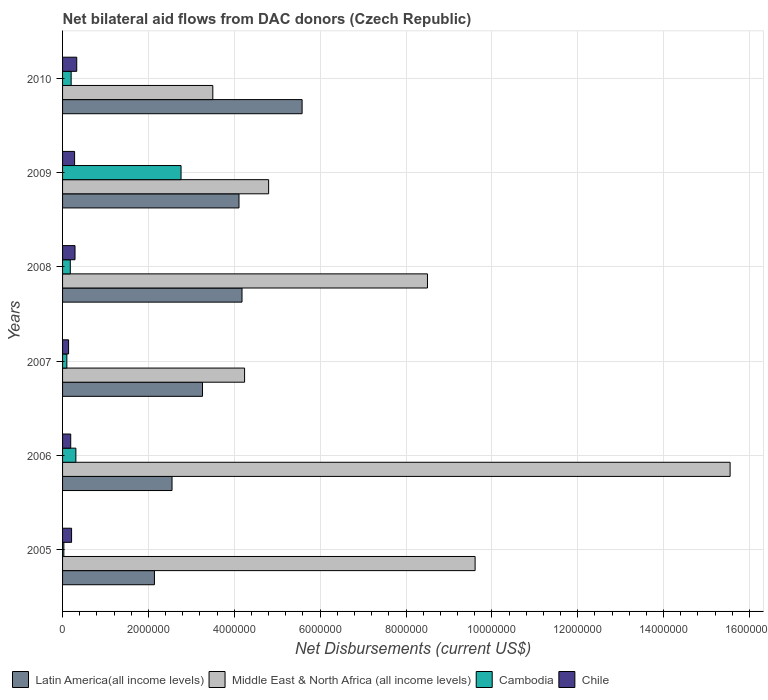How many bars are there on the 4th tick from the top?
Give a very brief answer. 4. How many bars are there on the 6th tick from the bottom?
Give a very brief answer. 4. What is the net bilateral aid flows in Latin America(all income levels) in 2008?
Provide a succinct answer. 4.18e+06. Across all years, what is the maximum net bilateral aid flows in Cambodia?
Your answer should be compact. 2.76e+06. Across all years, what is the minimum net bilateral aid flows in Middle East & North Africa (all income levels)?
Make the answer very short. 3.50e+06. In which year was the net bilateral aid flows in Cambodia maximum?
Ensure brevity in your answer.  2009. In which year was the net bilateral aid flows in Chile minimum?
Ensure brevity in your answer.  2007. What is the total net bilateral aid flows in Latin America(all income levels) in the graph?
Your response must be concise. 2.18e+07. What is the difference between the net bilateral aid flows in Cambodia in 2008 and that in 2009?
Your answer should be very brief. -2.58e+06. What is the difference between the net bilateral aid flows in Latin America(all income levels) in 2006 and the net bilateral aid flows in Middle East & North Africa (all income levels) in 2010?
Give a very brief answer. -9.50e+05. What is the average net bilateral aid flows in Middle East & North Africa (all income levels) per year?
Provide a succinct answer. 7.70e+06. In the year 2008, what is the difference between the net bilateral aid flows in Cambodia and net bilateral aid flows in Middle East & North Africa (all income levels)?
Give a very brief answer. -8.32e+06. What is the ratio of the net bilateral aid flows in Middle East & North Africa (all income levels) in 2005 to that in 2009?
Offer a very short reply. 2. Is the net bilateral aid flows in Latin America(all income levels) in 2007 less than that in 2010?
Your response must be concise. Yes. What is the difference between the highest and the second highest net bilateral aid flows in Middle East & North Africa (all income levels)?
Offer a terse response. 5.94e+06. What is the difference between the highest and the lowest net bilateral aid flows in Middle East & North Africa (all income levels)?
Make the answer very short. 1.20e+07. Is the sum of the net bilateral aid flows in Chile in 2007 and 2010 greater than the maximum net bilateral aid flows in Latin America(all income levels) across all years?
Offer a very short reply. No. Is it the case that in every year, the sum of the net bilateral aid flows in Latin America(all income levels) and net bilateral aid flows in Chile is greater than the sum of net bilateral aid flows in Middle East & North Africa (all income levels) and net bilateral aid flows in Cambodia?
Keep it short and to the point. No. What does the 4th bar from the top in 2010 represents?
Your answer should be compact. Latin America(all income levels). What does the 2nd bar from the bottom in 2009 represents?
Offer a terse response. Middle East & North Africa (all income levels). How many bars are there?
Provide a succinct answer. 24. Are all the bars in the graph horizontal?
Offer a terse response. Yes. Are the values on the major ticks of X-axis written in scientific E-notation?
Ensure brevity in your answer.  No. Does the graph contain any zero values?
Your answer should be very brief. No. Does the graph contain grids?
Keep it short and to the point. Yes. What is the title of the graph?
Offer a very short reply. Net bilateral aid flows from DAC donors (Czech Republic). What is the label or title of the X-axis?
Make the answer very short. Net Disbursements (current US$). What is the Net Disbursements (current US$) of Latin America(all income levels) in 2005?
Your answer should be very brief. 2.14e+06. What is the Net Disbursements (current US$) in Middle East & North Africa (all income levels) in 2005?
Offer a terse response. 9.61e+06. What is the Net Disbursements (current US$) of Latin America(all income levels) in 2006?
Keep it short and to the point. 2.55e+06. What is the Net Disbursements (current US$) of Middle East & North Africa (all income levels) in 2006?
Your answer should be compact. 1.56e+07. What is the Net Disbursements (current US$) in Chile in 2006?
Provide a succinct answer. 1.90e+05. What is the Net Disbursements (current US$) of Latin America(all income levels) in 2007?
Your answer should be very brief. 3.26e+06. What is the Net Disbursements (current US$) in Middle East & North Africa (all income levels) in 2007?
Give a very brief answer. 4.24e+06. What is the Net Disbursements (current US$) in Cambodia in 2007?
Make the answer very short. 1.00e+05. What is the Net Disbursements (current US$) of Latin America(all income levels) in 2008?
Keep it short and to the point. 4.18e+06. What is the Net Disbursements (current US$) of Middle East & North Africa (all income levels) in 2008?
Provide a short and direct response. 8.50e+06. What is the Net Disbursements (current US$) of Latin America(all income levels) in 2009?
Provide a succinct answer. 4.11e+06. What is the Net Disbursements (current US$) of Middle East & North Africa (all income levels) in 2009?
Provide a short and direct response. 4.80e+06. What is the Net Disbursements (current US$) in Cambodia in 2009?
Keep it short and to the point. 2.76e+06. What is the Net Disbursements (current US$) in Latin America(all income levels) in 2010?
Your answer should be compact. 5.58e+06. What is the Net Disbursements (current US$) of Middle East & North Africa (all income levels) in 2010?
Provide a succinct answer. 3.50e+06. What is the Net Disbursements (current US$) in Cambodia in 2010?
Your answer should be very brief. 2.00e+05. What is the Net Disbursements (current US$) in Chile in 2010?
Your response must be concise. 3.30e+05. Across all years, what is the maximum Net Disbursements (current US$) in Latin America(all income levels)?
Your answer should be compact. 5.58e+06. Across all years, what is the maximum Net Disbursements (current US$) of Middle East & North Africa (all income levels)?
Offer a terse response. 1.56e+07. Across all years, what is the maximum Net Disbursements (current US$) in Cambodia?
Provide a short and direct response. 2.76e+06. Across all years, what is the maximum Net Disbursements (current US$) of Chile?
Make the answer very short. 3.30e+05. Across all years, what is the minimum Net Disbursements (current US$) of Latin America(all income levels)?
Keep it short and to the point. 2.14e+06. Across all years, what is the minimum Net Disbursements (current US$) in Middle East & North Africa (all income levels)?
Provide a succinct answer. 3.50e+06. Across all years, what is the minimum Net Disbursements (current US$) in Cambodia?
Offer a terse response. 3.00e+04. Across all years, what is the minimum Net Disbursements (current US$) in Chile?
Your answer should be very brief. 1.40e+05. What is the total Net Disbursements (current US$) of Latin America(all income levels) in the graph?
Your response must be concise. 2.18e+07. What is the total Net Disbursements (current US$) in Middle East & North Africa (all income levels) in the graph?
Make the answer very short. 4.62e+07. What is the total Net Disbursements (current US$) in Cambodia in the graph?
Offer a very short reply. 3.58e+06. What is the total Net Disbursements (current US$) in Chile in the graph?
Your response must be concise. 1.44e+06. What is the difference between the Net Disbursements (current US$) in Latin America(all income levels) in 2005 and that in 2006?
Your answer should be compact. -4.10e+05. What is the difference between the Net Disbursements (current US$) of Middle East & North Africa (all income levels) in 2005 and that in 2006?
Keep it short and to the point. -5.94e+06. What is the difference between the Net Disbursements (current US$) in Cambodia in 2005 and that in 2006?
Ensure brevity in your answer.  -2.80e+05. What is the difference between the Net Disbursements (current US$) of Chile in 2005 and that in 2006?
Provide a short and direct response. 2.00e+04. What is the difference between the Net Disbursements (current US$) in Latin America(all income levels) in 2005 and that in 2007?
Your response must be concise. -1.12e+06. What is the difference between the Net Disbursements (current US$) of Middle East & North Africa (all income levels) in 2005 and that in 2007?
Keep it short and to the point. 5.37e+06. What is the difference between the Net Disbursements (current US$) in Latin America(all income levels) in 2005 and that in 2008?
Give a very brief answer. -2.04e+06. What is the difference between the Net Disbursements (current US$) of Middle East & North Africa (all income levels) in 2005 and that in 2008?
Ensure brevity in your answer.  1.11e+06. What is the difference between the Net Disbursements (current US$) in Cambodia in 2005 and that in 2008?
Your answer should be compact. -1.50e+05. What is the difference between the Net Disbursements (current US$) in Chile in 2005 and that in 2008?
Offer a very short reply. -8.00e+04. What is the difference between the Net Disbursements (current US$) in Latin America(all income levels) in 2005 and that in 2009?
Your answer should be very brief. -1.97e+06. What is the difference between the Net Disbursements (current US$) of Middle East & North Africa (all income levels) in 2005 and that in 2009?
Keep it short and to the point. 4.81e+06. What is the difference between the Net Disbursements (current US$) in Cambodia in 2005 and that in 2009?
Give a very brief answer. -2.73e+06. What is the difference between the Net Disbursements (current US$) in Chile in 2005 and that in 2009?
Keep it short and to the point. -7.00e+04. What is the difference between the Net Disbursements (current US$) of Latin America(all income levels) in 2005 and that in 2010?
Your answer should be very brief. -3.44e+06. What is the difference between the Net Disbursements (current US$) in Middle East & North Africa (all income levels) in 2005 and that in 2010?
Ensure brevity in your answer.  6.11e+06. What is the difference between the Net Disbursements (current US$) of Cambodia in 2005 and that in 2010?
Ensure brevity in your answer.  -1.70e+05. What is the difference between the Net Disbursements (current US$) of Chile in 2005 and that in 2010?
Offer a terse response. -1.20e+05. What is the difference between the Net Disbursements (current US$) of Latin America(all income levels) in 2006 and that in 2007?
Offer a terse response. -7.10e+05. What is the difference between the Net Disbursements (current US$) in Middle East & North Africa (all income levels) in 2006 and that in 2007?
Make the answer very short. 1.13e+07. What is the difference between the Net Disbursements (current US$) in Cambodia in 2006 and that in 2007?
Give a very brief answer. 2.10e+05. What is the difference between the Net Disbursements (current US$) in Latin America(all income levels) in 2006 and that in 2008?
Give a very brief answer. -1.63e+06. What is the difference between the Net Disbursements (current US$) in Middle East & North Africa (all income levels) in 2006 and that in 2008?
Your answer should be very brief. 7.05e+06. What is the difference between the Net Disbursements (current US$) of Cambodia in 2006 and that in 2008?
Your answer should be compact. 1.30e+05. What is the difference between the Net Disbursements (current US$) of Latin America(all income levels) in 2006 and that in 2009?
Make the answer very short. -1.56e+06. What is the difference between the Net Disbursements (current US$) of Middle East & North Africa (all income levels) in 2006 and that in 2009?
Provide a succinct answer. 1.08e+07. What is the difference between the Net Disbursements (current US$) of Cambodia in 2006 and that in 2009?
Your answer should be very brief. -2.45e+06. What is the difference between the Net Disbursements (current US$) in Chile in 2006 and that in 2009?
Keep it short and to the point. -9.00e+04. What is the difference between the Net Disbursements (current US$) in Latin America(all income levels) in 2006 and that in 2010?
Give a very brief answer. -3.03e+06. What is the difference between the Net Disbursements (current US$) of Middle East & North Africa (all income levels) in 2006 and that in 2010?
Give a very brief answer. 1.20e+07. What is the difference between the Net Disbursements (current US$) in Cambodia in 2006 and that in 2010?
Offer a terse response. 1.10e+05. What is the difference between the Net Disbursements (current US$) of Latin America(all income levels) in 2007 and that in 2008?
Offer a very short reply. -9.20e+05. What is the difference between the Net Disbursements (current US$) in Middle East & North Africa (all income levels) in 2007 and that in 2008?
Provide a short and direct response. -4.26e+06. What is the difference between the Net Disbursements (current US$) in Latin America(all income levels) in 2007 and that in 2009?
Give a very brief answer. -8.50e+05. What is the difference between the Net Disbursements (current US$) of Middle East & North Africa (all income levels) in 2007 and that in 2009?
Give a very brief answer. -5.60e+05. What is the difference between the Net Disbursements (current US$) of Cambodia in 2007 and that in 2009?
Offer a terse response. -2.66e+06. What is the difference between the Net Disbursements (current US$) of Latin America(all income levels) in 2007 and that in 2010?
Provide a short and direct response. -2.32e+06. What is the difference between the Net Disbursements (current US$) in Middle East & North Africa (all income levels) in 2007 and that in 2010?
Ensure brevity in your answer.  7.40e+05. What is the difference between the Net Disbursements (current US$) in Cambodia in 2007 and that in 2010?
Give a very brief answer. -1.00e+05. What is the difference between the Net Disbursements (current US$) in Middle East & North Africa (all income levels) in 2008 and that in 2009?
Keep it short and to the point. 3.70e+06. What is the difference between the Net Disbursements (current US$) of Cambodia in 2008 and that in 2009?
Keep it short and to the point. -2.58e+06. What is the difference between the Net Disbursements (current US$) of Chile in 2008 and that in 2009?
Your answer should be very brief. 10000. What is the difference between the Net Disbursements (current US$) in Latin America(all income levels) in 2008 and that in 2010?
Offer a very short reply. -1.40e+06. What is the difference between the Net Disbursements (current US$) in Middle East & North Africa (all income levels) in 2008 and that in 2010?
Make the answer very short. 5.00e+06. What is the difference between the Net Disbursements (current US$) in Cambodia in 2008 and that in 2010?
Ensure brevity in your answer.  -2.00e+04. What is the difference between the Net Disbursements (current US$) of Latin America(all income levels) in 2009 and that in 2010?
Provide a short and direct response. -1.47e+06. What is the difference between the Net Disbursements (current US$) in Middle East & North Africa (all income levels) in 2009 and that in 2010?
Keep it short and to the point. 1.30e+06. What is the difference between the Net Disbursements (current US$) of Cambodia in 2009 and that in 2010?
Provide a succinct answer. 2.56e+06. What is the difference between the Net Disbursements (current US$) in Chile in 2009 and that in 2010?
Your answer should be compact. -5.00e+04. What is the difference between the Net Disbursements (current US$) of Latin America(all income levels) in 2005 and the Net Disbursements (current US$) of Middle East & North Africa (all income levels) in 2006?
Your response must be concise. -1.34e+07. What is the difference between the Net Disbursements (current US$) in Latin America(all income levels) in 2005 and the Net Disbursements (current US$) in Cambodia in 2006?
Offer a terse response. 1.83e+06. What is the difference between the Net Disbursements (current US$) in Latin America(all income levels) in 2005 and the Net Disbursements (current US$) in Chile in 2006?
Provide a short and direct response. 1.95e+06. What is the difference between the Net Disbursements (current US$) of Middle East & North Africa (all income levels) in 2005 and the Net Disbursements (current US$) of Cambodia in 2006?
Your answer should be very brief. 9.30e+06. What is the difference between the Net Disbursements (current US$) in Middle East & North Africa (all income levels) in 2005 and the Net Disbursements (current US$) in Chile in 2006?
Provide a succinct answer. 9.42e+06. What is the difference between the Net Disbursements (current US$) of Latin America(all income levels) in 2005 and the Net Disbursements (current US$) of Middle East & North Africa (all income levels) in 2007?
Give a very brief answer. -2.10e+06. What is the difference between the Net Disbursements (current US$) in Latin America(all income levels) in 2005 and the Net Disbursements (current US$) in Cambodia in 2007?
Make the answer very short. 2.04e+06. What is the difference between the Net Disbursements (current US$) of Middle East & North Africa (all income levels) in 2005 and the Net Disbursements (current US$) of Cambodia in 2007?
Your response must be concise. 9.51e+06. What is the difference between the Net Disbursements (current US$) in Middle East & North Africa (all income levels) in 2005 and the Net Disbursements (current US$) in Chile in 2007?
Your answer should be very brief. 9.47e+06. What is the difference between the Net Disbursements (current US$) of Latin America(all income levels) in 2005 and the Net Disbursements (current US$) of Middle East & North Africa (all income levels) in 2008?
Your answer should be very brief. -6.36e+06. What is the difference between the Net Disbursements (current US$) in Latin America(all income levels) in 2005 and the Net Disbursements (current US$) in Cambodia in 2008?
Your response must be concise. 1.96e+06. What is the difference between the Net Disbursements (current US$) of Latin America(all income levels) in 2005 and the Net Disbursements (current US$) of Chile in 2008?
Offer a very short reply. 1.85e+06. What is the difference between the Net Disbursements (current US$) of Middle East & North Africa (all income levels) in 2005 and the Net Disbursements (current US$) of Cambodia in 2008?
Keep it short and to the point. 9.43e+06. What is the difference between the Net Disbursements (current US$) in Middle East & North Africa (all income levels) in 2005 and the Net Disbursements (current US$) in Chile in 2008?
Give a very brief answer. 9.32e+06. What is the difference between the Net Disbursements (current US$) in Cambodia in 2005 and the Net Disbursements (current US$) in Chile in 2008?
Offer a terse response. -2.60e+05. What is the difference between the Net Disbursements (current US$) in Latin America(all income levels) in 2005 and the Net Disbursements (current US$) in Middle East & North Africa (all income levels) in 2009?
Keep it short and to the point. -2.66e+06. What is the difference between the Net Disbursements (current US$) of Latin America(all income levels) in 2005 and the Net Disbursements (current US$) of Cambodia in 2009?
Keep it short and to the point. -6.20e+05. What is the difference between the Net Disbursements (current US$) in Latin America(all income levels) in 2005 and the Net Disbursements (current US$) in Chile in 2009?
Provide a succinct answer. 1.86e+06. What is the difference between the Net Disbursements (current US$) of Middle East & North Africa (all income levels) in 2005 and the Net Disbursements (current US$) of Cambodia in 2009?
Your response must be concise. 6.85e+06. What is the difference between the Net Disbursements (current US$) of Middle East & North Africa (all income levels) in 2005 and the Net Disbursements (current US$) of Chile in 2009?
Provide a short and direct response. 9.33e+06. What is the difference between the Net Disbursements (current US$) in Latin America(all income levels) in 2005 and the Net Disbursements (current US$) in Middle East & North Africa (all income levels) in 2010?
Provide a succinct answer. -1.36e+06. What is the difference between the Net Disbursements (current US$) in Latin America(all income levels) in 2005 and the Net Disbursements (current US$) in Cambodia in 2010?
Offer a very short reply. 1.94e+06. What is the difference between the Net Disbursements (current US$) in Latin America(all income levels) in 2005 and the Net Disbursements (current US$) in Chile in 2010?
Give a very brief answer. 1.81e+06. What is the difference between the Net Disbursements (current US$) of Middle East & North Africa (all income levels) in 2005 and the Net Disbursements (current US$) of Cambodia in 2010?
Provide a short and direct response. 9.41e+06. What is the difference between the Net Disbursements (current US$) in Middle East & North Africa (all income levels) in 2005 and the Net Disbursements (current US$) in Chile in 2010?
Your response must be concise. 9.28e+06. What is the difference between the Net Disbursements (current US$) of Latin America(all income levels) in 2006 and the Net Disbursements (current US$) of Middle East & North Africa (all income levels) in 2007?
Give a very brief answer. -1.69e+06. What is the difference between the Net Disbursements (current US$) of Latin America(all income levels) in 2006 and the Net Disbursements (current US$) of Cambodia in 2007?
Make the answer very short. 2.45e+06. What is the difference between the Net Disbursements (current US$) in Latin America(all income levels) in 2006 and the Net Disbursements (current US$) in Chile in 2007?
Give a very brief answer. 2.41e+06. What is the difference between the Net Disbursements (current US$) in Middle East & North Africa (all income levels) in 2006 and the Net Disbursements (current US$) in Cambodia in 2007?
Your answer should be compact. 1.54e+07. What is the difference between the Net Disbursements (current US$) of Middle East & North Africa (all income levels) in 2006 and the Net Disbursements (current US$) of Chile in 2007?
Provide a succinct answer. 1.54e+07. What is the difference between the Net Disbursements (current US$) of Latin America(all income levels) in 2006 and the Net Disbursements (current US$) of Middle East & North Africa (all income levels) in 2008?
Provide a short and direct response. -5.95e+06. What is the difference between the Net Disbursements (current US$) of Latin America(all income levels) in 2006 and the Net Disbursements (current US$) of Cambodia in 2008?
Your response must be concise. 2.37e+06. What is the difference between the Net Disbursements (current US$) of Latin America(all income levels) in 2006 and the Net Disbursements (current US$) of Chile in 2008?
Your answer should be compact. 2.26e+06. What is the difference between the Net Disbursements (current US$) in Middle East & North Africa (all income levels) in 2006 and the Net Disbursements (current US$) in Cambodia in 2008?
Your answer should be compact. 1.54e+07. What is the difference between the Net Disbursements (current US$) in Middle East & North Africa (all income levels) in 2006 and the Net Disbursements (current US$) in Chile in 2008?
Provide a succinct answer. 1.53e+07. What is the difference between the Net Disbursements (current US$) of Latin America(all income levels) in 2006 and the Net Disbursements (current US$) of Middle East & North Africa (all income levels) in 2009?
Your answer should be very brief. -2.25e+06. What is the difference between the Net Disbursements (current US$) of Latin America(all income levels) in 2006 and the Net Disbursements (current US$) of Cambodia in 2009?
Ensure brevity in your answer.  -2.10e+05. What is the difference between the Net Disbursements (current US$) of Latin America(all income levels) in 2006 and the Net Disbursements (current US$) of Chile in 2009?
Your answer should be compact. 2.27e+06. What is the difference between the Net Disbursements (current US$) in Middle East & North Africa (all income levels) in 2006 and the Net Disbursements (current US$) in Cambodia in 2009?
Your answer should be compact. 1.28e+07. What is the difference between the Net Disbursements (current US$) of Middle East & North Africa (all income levels) in 2006 and the Net Disbursements (current US$) of Chile in 2009?
Provide a short and direct response. 1.53e+07. What is the difference between the Net Disbursements (current US$) of Latin America(all income levels) in 2006 and the Net Disbursements (current US$) of Middle East & North Africa (all income levels) in 2010?
Keep it short and to the point. -9.50e+05. What is the difference between the Net Disbursements (current US$) of Latin America(all income levels) in 2006 and the Net Disbursements (current US$) of Cambodia in 2010?
Your answer should be very brief. 2.35e+06. What is the difference between the Net Disbursements (current US$) in Latin America(all income levels) in 2006 and the Net Disbursements (current US$) in Chile in 2010?
Offer a very short reply. 2.22e+06. What is the difference between the Net Disbursements (current US$) in Middle East & North Africa (all income levels) in 2006 and the Net Disbursements (current US$) in Cambodia in 2010?
Offer a terse response. 1.54e+07. What is the difference between the Net Disbursements (current US$) in Middle East & North Africa (all income levels) in 2006 and the Net Disbursements (current US$) in Chile in 2010?
Provide a short and direct response. 1.52e+07. What is the difference between the Net Disbursements (current US$) of Latin America(all income levels) in 2007 and the Net Disbursements (current US$) of Middle East & North Africa (all income levels) in 2008?
Your answer should be compact. -5.24e+06. What is the difference between the Net Disbursements (current US$) of Latin America(all income levels) in 2007 and the Net Disbursements (current US$) of Cambodia in 2008?
Offer a very short reply. 3.08e+06. What is the difference between the Net Disbursements (current US$) of Latin America(all income levels) in 2007 and the Net Disbursements (current US$) of Chile in 2008?
Provide a short and direct response. 2.97e+06. What is the difference between the Net Disbursements (current US$) in Middle East & North Africa (all income levels) in 2007 and the Net Disbursements (current US$) in Cambodia in 2008?
Offer a terse response. 4.06e+06. What is the difference between the Net Disbursements (current US$) in Middle East & North Africa (all income levels) in 2007 and the Net Disbursements (current US$) in Chile in 2008?
Your answer should be compact. 3.95e+06. What is the difference between the Net Disbursements (current US$) of Cambodia in 2007 and the Net Disbursements (current US$) of Chile in 2008?
Provide a succinct answer. -1.90e+05. What is the difference between the Net Disbursements (current US$) in Latin America(all income levels) in 2007 and the Net Disbursements (current US$) in Middle East & North Africa (all income levels) in 2009?
Make the answer very short. -1.54e+06. What is the difference between the Net Disbursements (current US$) in Latin America(all income levels) in 2007 and the Net Disbursements (current US$) in Cambodia in 2009?
Provide a short and direct response. 5.00e+05. What is the difference between the Net Disbursements (current US$) of Latin America(all income levels) in 2007 and the Net Disbursements (current US$) of Chile in 2009?
Make the answer very short. 2.98e+06. What is the difference between the Net Disbursements (current US$) of Middle East & North Africa (all income levels) in 2007 and the Net Disbursements (current US$) of Cambodia in 2009?
Give a very brief answer. 1.48e+06. What is the difference between the Net Disbursements (current US$) of Middle East & North Africa (all income levels) in 2007 and the Net Disbursements (current US$) of Chile in 2009?
Give a very brief answer. 3.96e+06. What is the difference between the Net Disbursements (current US$) of Latin America(all income levels) in 2007 and the Net Disbursements (current US$) of Cambodia in 2010?
Keep it short and to the point. 3.06e+06. What is the difference between the Net Disbursements (current US$) of Latin America(all income levels) in 2007 and the Net Disbursements (current US$) of Chile in 2010?
Give a very brief answer. 2.93e+06. What is the difference between the Net Disbursements (current US$) in Middle East & North Africa (all income levels) in 2007 and the Net Disbursements (current US$) in Cambodia in 2010?
Your answer should be very brief. 4.04e+06. What is the difference between the Net Disbursements (current US$) in Middle East & North Africa (all income levels) in 2007 and the Net Disbursements (current US$) in Chile in 2010?
Make the answer very short. 3.91e+06. What is the difference between the Net Disbursements (current US$) in Latin America(all income levels) in 2008 and the Net Disbursements (current US$) in Middle East & North Africa (all income levels) in 2009?
Your response must be concise. -6.20e+05. What is the difference between the Net Disbursements (current US$) of Latin America(all income levels) in 2008 and the Net Disbursements (current US$) of Cambodia in 2009?
Your answer should be compact. 1.42e+06. What is the difference between the Net Disbursements (current US$) of Latin America(all income levels) in 2008 and the Net Disbursements (current US$) of Chile in 2009?
Offer a terse response. 3.90e+06. What is the difference between the Net Disbursements (current US$) in Middle East & North Africa (all income levels) in 2008 and the Net Disbursements (current US$) in Cambodia in 2009?
Ensure brevity in your answer.  5.74e+06. What is the difference between the Net Disbursements (current US$) of Middle East & North Africa (all income levels) in 2008 and the Net Disbursements (current US$) of Chile in 2009?
Provide a succinct answer. 8.22e+06. What is the difference between the Net Disbursements (current US$) in Latin America(all income levels) in 2008 and the Net Disbursements (current US$) in Middle East & North Africa (all income levels) in 2010?
Offer a very short reply. 6.80e+05. What is the difference between the Net Disbursements (current US$) of Latin America(all income levels) in 2008 and the Net Disbursements (current US$) of Cambodia in 2010?
Keep it short and to the point. 3.98e+06. What is the difference between the Net Disbursements (current US$) in Latin America(all income levels) in 2008 and the Net Disbursements (current US$) in Chile in 2010?
Make the answer very short. 3.85e+06. What is the difference between the Net Disbursements (current US$) in Middle East & North Africa (all income levels) in 2008 and the Net Disbursements (current US$) in Cambodia in 2010?
Provide a short and direct response. 8.30e+06. What is the difference between the Net Disbursements (current US$) of Middle East & North Africa (all income levels) in 2008 and the Net Disbursements (current US$) of Chile in 2010?
Offer a very short reply. 8.17e+06. What is the difference between the Net Disbursements (current US$) in Cambodia in 2008 and the Net Disbursements (current US$) in Chile in 2010?
Your answer should be compact. -1.50e+05. What is the difference between the Net Disbursements (current US$) in Latin America(all income levels) in 2009 and the Net Disbursements (current US$) in Cambodia in 2010?
Your response must be concise. 3.91e+06. What is the difference between the Net Disbursements (current US$) of Latin America(all income levels) in 2009 and the Net Disbursements (current US$) of Chile in 2010?
Ensure brevity in your answer.  3.78e+06. What is the difference between the Net Disbursements (current US$) of Middle East & North Africa (all income levels) in 2009 and the Net Disbursements (current US$) of Cambodia in 2010?
Give a very brief answer. 4.60e+06. What is the difference between the Net Disbursements (current US$) in Middle East & North Africa (all income levels) in 2009 and the Net Disbursements (current US$) in Chile in 2010?
Your response must be concise. 4.47e+06. What is the difference between the Net Disbursements (current US$) in Cambodia in 2009 and the Net Disbursements (current US$) in Chile in 2010?
Provide a short and direct response. 2.43e+06. What is the average Net Disbursements (current US$) of Latin America(all income levels) per year?
Offer a terse response. 3.64e+06. What is the average Net Disbursements (current US$) in Middle East & North Africa (all income levels) per year?
Make the answer very short. 7.70e+06. What is the average Net Disbursements (current US$) of Cambodia per year?
Ensure brevity in your answer.  5.97e+05. What is the average Net Disbursements (current US$) in Chile per year?
Provide a short and direct response. 2.40e+05. In the year 2005, what is the difference between the Net Disbursements (current US$) of Latin America(all income levels) and Net Disbursements (current US$) of Middle East & North Africa (all income levels)?
Provide a short and direct response. -7.47e+06. In the year 2005, what is the difference between the Net Disbursements (current US$) of Latin America(all income levels) and Net Disbursements (current US$) of Cambodia?
Offer a very short reply. 2.11e+06. In the year 2005, what is the difference between the Net Disbursements (current US$) of Latin America(all income levels) and Net Disbursements (current US$) of Chile?
Your response must be concise. 1.93e+06. In the year 2005, what is the difference between the Net Disbursements (current US$) in Middle East & North Africa (all income levels) and Net Disbursements (current US$) in Cambodia?
Give a very brief answer. 9.58e+06. In the year 2005, what is the difference between the Net Disbursements (current US$) in Middle East & North Africa (all income levels) and Net Disbursements (current US$) in Chile?
Offer a very short reply. 9.40e+06. In the year 2005, what is the difference between the Net Disbursements (current US$) in Cambodia and Net Disbursements (current US$) in Chile?
Give a very brief answer. -1.80e+05. In the year 2006, what is the difference between the Net Disbursements (current US$) in Latin America(all income levels) and Net Disbursements (current US$) in Middle East & North Africa (all income levels)?
Keep it short and to the point. -1.30e+07. In the year 2006, what is the difference between the Net Disbursements (current US$) in Latin America(all income levels) and Net Disbursements (current US$) in Cambodia?
Provide a short and direct response. 2.24e+06. In the year 2006, what is the difference between the Net Disbursements (current US$) of Latin America(all income levels) and Net Disbursements (current US$) of Chile?
Offer a terse response. 2.36e+06. In the year 2006, what is the difference between the Net Disbursements (current US$) of Middle East & North Africa (all income levels) and Net Disbursements (current US$) of Cambodia?
Give a very brief answer. 1.52e+07. In the year 2006, what is the difference between the Net Disbursements (current US$) of Middle East & North Africa (all income levels) and Net Disbursements (current US$) of Chile?
Your answer should be compact. 1.54e+07. In the year 2006, what is the difference between the Net Disbursements (current US$) of Cambodia and Net Disbursements (current US$) of Chile?
Give a very brief answer. 1.20e+05. In the year 2007, what is the difference between the Net Disbursements (current US$) in Latin America(all income levels) and Net Disbursements (current US$) in Middle East & North Africa (all income levels)?
Your answer should be very brief. -9.80e+05. In the year 2007, what is the difference between the Net Disbursements (current US$) of Latin America(all income levels) and Net Disbursements (current US$) of Cambodia?
Your answer should be very brief. 3.16e+06. In the year 2007, what is the difference between the Net Disbursements (current US$) of Latin America(all income levels) and Net Disbursements (current US$) of Chile?
Your response must be concise. 3.12e+06. In the year 2007, what is the difference between the Net Disbursements (current US$) of Middle East & North Africa (all income levels) and Net Disbursements (current US$) of Cambodia?
Your answer should be compact. 4.14e+06. In the year 2007, what is the difference between the Net Disbursements (current US$) in Middle East & North Africa (all income levels) and Net Disbursements (current US$) in Chile?
Offer a very short reply. 4.10e+06. In the year 2007, what is the difference between the Net Disbursements (current US$) in Cambodia and Net Disbursements (current US$) in Chile?
Provide a short and direct response. -4.00e+04. In the year 2008, what is the difference between the Net Disbursements (current US$) of Latin America(all income levels) and Net Disbursements (current US$) of Middle East & North Africa (all income levels)?
Offer a terse response. -4.32e+06. In the year 2008, what is the difference between the Net Disbursements (current US$) of Latin America(all income levels) and Net Disbursements (current US$) of Chile?
Provide a succinct answer. 3.89e+06. In the year 2008, what is the difference between the Net Disbursements (current US$) in Middle East & North Africa (all income levels) and Net Disbursements (current US$) in Cambodia?
Your answer should be very brief. 8.32e+06. In the year 2008, what is the difference between the Net Disbursements (current US$) of Middle East & North Africa (all income levels) and Net Disbursements (current US$) of Chile?
Your answer should be compact. 8.21e+06. In the year 2008, what is the difference between the Net Disbursements (current US$) in Cambodia and Net Disbursements (current US$) in Chile?
Your answer should be compact. -1.10e+05. In the year 2009, what is the difference between the Net Disbursements (current US$) of Latin America(all income levels) and Net Disbursements (current US$) of Middle East & North Africa (all income levels)?
Provide a short and direct response. -6.90e+05. In the year 2009, what is the difference between the Net Disbursements (current US$) in Latin America(all income levels) and Net Disbursements (current US$) in Cambodia?
Provide a succinct answer. 1.35e+06. In the year 2009, what is the difference between the Net Disbursements (current US$) of Latin America(all income levels) and Net Disbursements (current US$) of Chile?
Your answer should be compact. 3.83e+06. In the year 2009, what is the difference between the Net Disbursements (current US$) in Middle East & North Africa (all income levels) and Net Disbursements (current US$) in Cambodia?
Provide a succinct answer. 2.04e+06. In the year 2009, what is the difference between the Net Disbursements (current US$) in Middle East & North Africa (all income levels) and Net Disbursements (current US$) in Chile?
Provide a short and direct response. 4.52e+06. In the year 2009, what is the difference between the Net Disbursements (current US$) of Cambodia and Net Disbursements (current US$) of Chile?
Keep it short and to the point. 2.48e+06. In the year 2010, what is the difference between the Net Disbursements (current US$) of Latin America(all income levels) and Net Disbursements (current US$) of Middle East & North Africa (all income levels)?
Ensure brevity in your answer.  2.08e+06. In the year 2010, what is the difference between the Net Disbursements (current US$) of Latin America(all income levels) and Net Disbursements (current US$) of Cambodia?
Make the answer very short. 5.38e+06. In the year 2010, what is the difference between the Net Disbursements (current US$) in Latin America(all income levels) and Net Disbursements (current US$) in Chile?
Provide a succinct answer. 5.25e+06. In the year 2010, what is the difference between the Net Disbursements (current US$) in Middle East & North Africa (all income levels) and Net Disbursements (current US$) in Cambodia?
Offer a terse response. 3.30e+06. In the year 2010, what is the difference between the Net Disbursements (current US$) of Middle East & North Africa (all income levels) and Net Disbursements (current US$) of Chile?
Offer a terse response. 3.17e+06. What is the ratio of the Net Disbursements (current US$) in Latin America(all income levels) in 2005 to that in 2006?
Your response must be concise. 0.84. What is the ratio of the Net Disbursements (current US$) of Middle East & North Africa (all income levels) in 2005 to that in 2006?
Your answer should be very brief. 0.62. What is the ratio of the Net Disbursements (current US$) of Cambodia in 2005 to that in 2006?
Ensure brevity in your answer.  0.1. What is the ratio of the Net Disbursements (current US$) of Chile in 2005 to that in 2006?
Your response must be concise. 1.11. What is the ratio of the Net Disbursements (current US$) in Latin America(all income levels) in 2005 to that in 2007?
Your response must be concise. 0.66. What is the ratio of the Net Disbursements (current US$) in Middle East & North Africa (all income levels) in 2005 to that in 2007?
Make the answer very short. 2.27. What is the ratio of the Net Disbursements (current US$) of Chile in 2005 to that in 2007?
Provide a succinct answer. 1.5. What is the ratio of the Net Disbursements (current US$) in Latin America(all income levels) in 2005 to that in 2008?
Provide a short and direct response. 0.51. What is the ratio of the Net Disbursements (current US$) in Middle East & North Africa (all income levels) in 2005 to that in 2008?
Your answer should be very brief. 1.13. What is the ratio of the Net Disbursements (current US$) in Chile in 2005 to that in 2008?
Make the answer very short. 0.72. What is the ratio of the Net Disbursements (current US$) in Latin America(all income levels) in 2005 to that in 2009?
Your answer should be very brief. 0.52. What is the ratio of the Net Disbursements (current US$) in Middle East & North Africa (all income levels) in 2005 to that in 2009?
Keep it short and to the point. 2. What is the ratio of the Net Disbursements (current US$) in Cambodia in 2005 to that in 2009?
Offer a very short reply. 0.01. What is the ratio of the Net Disbursements (current US$) in Latin America(all income levels) in 2005 to that in 2010?
Your response must be concise. 0.38. What is the ratio of the Net Disbursements (current US$) in Middle East & North Africa (all income levels) in 2005 to that in 2010?
Keep it short and to the point. 2.75. What is the ratio of the Net Disbursements (current US$) in Chile in 2005 to that in 2010?
Keep it short and to the point. 0.64. What is the ratio of the Net Disbursements (current US$) of Latin America(all income levels) in 2006 to that in 2007?
Give a very brief answer. 0.78. What is the ratio of the Net Disbursements (current US$) in Middle East & North Africa (all income levels) in 2006 to that in 2007?
Ensure brevity in your answer.  3.67. What is the ratio of the Net Disbursements (current US$) of Cambodia in 2006 to that in 2007?
Make the answer very short. 3.1. What is the ratio of the Net Disbursements (current US$) in Chile in 2006 to that in 2007?
Your response must be concise. 1.36. What is the ratio of the Net Disbursements (current US$) in Latin America(all income levels) in 2006 to that in 2008?
Make the answer very short. 0.61. What is the ratio of the Net Disbursements (current US$) of Middle East & North Africa (all income levels) in 2006 to that in 2008?
Your answer should be compact. 1.83. What is the ratio of the Net Disbursements (current US$) of Cambodia in 2006 to that in 2008?
Keep it short and to the point. 1.72. What is the ratio of the Net Disbursements (current US$) in Chile in 2006 to that in 2008?
Provide a succinct answer. 0.66. What is the ratio of the Net Disbursements (current US$) in Latin America(all income levels) in 2006 to that in 2009?
Your answer should be compact. 0.62. What is the ratio of the Net Disbursements (current US$) in Middle East & North Africa (all income levels) in 2006 to that in 2009?
Provide a short and direct response. 3.24. What is the ratio of the Net Disbursements (current US$) in Cambodia in 2006 to that in 2009?
Ensure brevity in your answer.  0.11. What is the ratio of the Net Disbursements (current US$) of Chile in 2006 to that in 2009?
Your answer should be compact. 0.68. What is the ratio of the Net Disbursements (current US$) in Latin America(all income levels) in 2006 to that in 2010?
Your answer should be very brief. 0.46. What is the ratio of the Net Disbursements (current US$) in Middle East & North Africa (all income levels) in 2006 to that in 2010?
Your answer should be very brief. 4.44. What is the ratio of the Net Disbursements (current US$) of Cambodia in 2006 to that in 2010?
Your answer should be very brief. 1.55. What is the ratio of the Net Disbursements (current US$) in Chile in 2006 to that in 2010?
Provide a short and direct response. 0.58. What is the ratio of the Net Disbursements (current US$) of Latin America(all income levels) in 2007 to that in 2008?
Provide a short and direct response. 0.78. What is the ratio of the Net Disbursements (current US$) of Middle East & North Africa (all income levels) in 2007 to that in 2008?
Provide a succinct answer. 0.5. What is the ratio of the Net Disbursements (current US$) of Cambodia in 2007 to that in 2008?
Provide a short and direct response. 0.56. What is the ratio of the Net Disbursements (current US$) in Chile in 2007 to that in 2008?
Give a very brief answer. 0.48. What is the ratio of the Net Disbursements (current US$) in Latin America(all income levels) in 2007 to that in 2009?
Your answer should be very brief. 0.79. What is the ratio of the Net Disbursements (current US$) in Middle East & North Africa (all income levels) in 2007 to that in 2009?
Keep it short and to the point. 0.88. What is the ratio of the Net Disbursements (current US$) in Cambodia in 2007 to that in 2009?
Make the answer very short. 0.04. What is the ratio of the Net Disbursements (current US$) of Chile in 2007 to that in 2009?
Make the answer very short. 0.5. What is the ratio of the Net Disbursements (current US$) of Latin America(all income levels) in 2007 to that in 2010?
Offer a very short reply. 0.58. What is the ratio of the Net Disbursements (current US$) in Middle East & North Africa (all income levels) in 2007 to that in 2010?
Your answer should be compact. 1.21. What is the ratio of the Net Disbursements (current US$) of Chile in 2007 to that in 2010?
Provide a short and direct response. 0.42. What is the ratio of the Net Disbursements (current US$) in Middle East & North Africa (all income levels) in 2008 to that in 2009?
Give a very brief answer. 1.77. What is the ratio of the Net Disbursements (current US$) of Cambodia in 2008 to that in 2009?
Ensure brevity in your answer.  0.07. What is the ratio of the Net Disbursements (current US$) of Chile in 2008 to that in 2009?
Offer a very short reply. 1.04. What is the ratio of the Net Disbursements (current US$) of Latin America(all income levels) in 2008 to that in 2010?
Provide a succinct answer. 0.75. What is the ratio of the Net Disbursements (current US$) of Middle East & North Africa (all income levels) in 2008 to that in 2010?
Your response must be concise. 2.43. What is the ratio of the Net Disbursements (current US$) of Chile in 2008 to that in 2010?
Your response must be concise. 0.88. What is the ratio of the Net Disbursements (current US$) in Latin America(all income levels) in 2009 to that in 2010?
Your response must be concise. 0.74. What is the ratio of the Net Disbursements (current US$) of Middle East & North Africa (all income levels) in 2009 to that in 2010?
Provide a succinct answer. 1.37. What is the ratio of the Net Disbursements (current US$) in Chile in 2009 to that in 2010?
Offer a terse response. 0.85. What is the difference between the highest and the second highest Net Disbursements (current US$) of Latin America(all income levels)?
Your response must be concise. 1.40e+06. What is the difference between the highest and the second highest Net Disbursements (current US$) in Middle East & North Africa (all income levels)?
Keep it short and to the point. 5.94e+06. What is the difference between the highest and the second highest Net Disbursements (current US$) in Cambodia?
Keep it short and to the point. 2.45e+06. What is the difference between the highest and the second highest Net Disbursements (current US$) of Chile?
Give a very brief answer. 4.00e+04. What is the difference between the highest and the lowest Net Disbursements (current US$) in Latin America(all income levels)?
Your answer should be compact. 3.44e+06. What is the difference between the highest and the lowest Net Disbursements (current US$) of Middle East & North Africa (all income levels)?
Ensure brevity in your answer.  1.20e+07. What is the difference between the highest and the lowest Net Disbursements (current US$) in Cambodia?
Keep it short and to the point. 2.73e+06. 